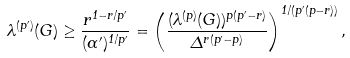<formula> <loc_0><loc_0><loc_500><loc_500>\lambda ^ { ( p ^ { \prime } ) } ( G ) \geq \frac { r ^ { 1 - r / p ^ { \prime } } } { ( \alpha ^ { \prime } ) ^ { 1 / p ^ { \prime } } } = \left ( \frac { ( \lambda ^ { ( p ) } ( G ) ) ^ { p ( p ^ { \prime } - r ) } } { \Delta ^ { r ( p ^ { \prime } - p ) } } \right ) ^ { 1 / ( p ^ { \prime } ( p - r ) ) } ,</formula> 